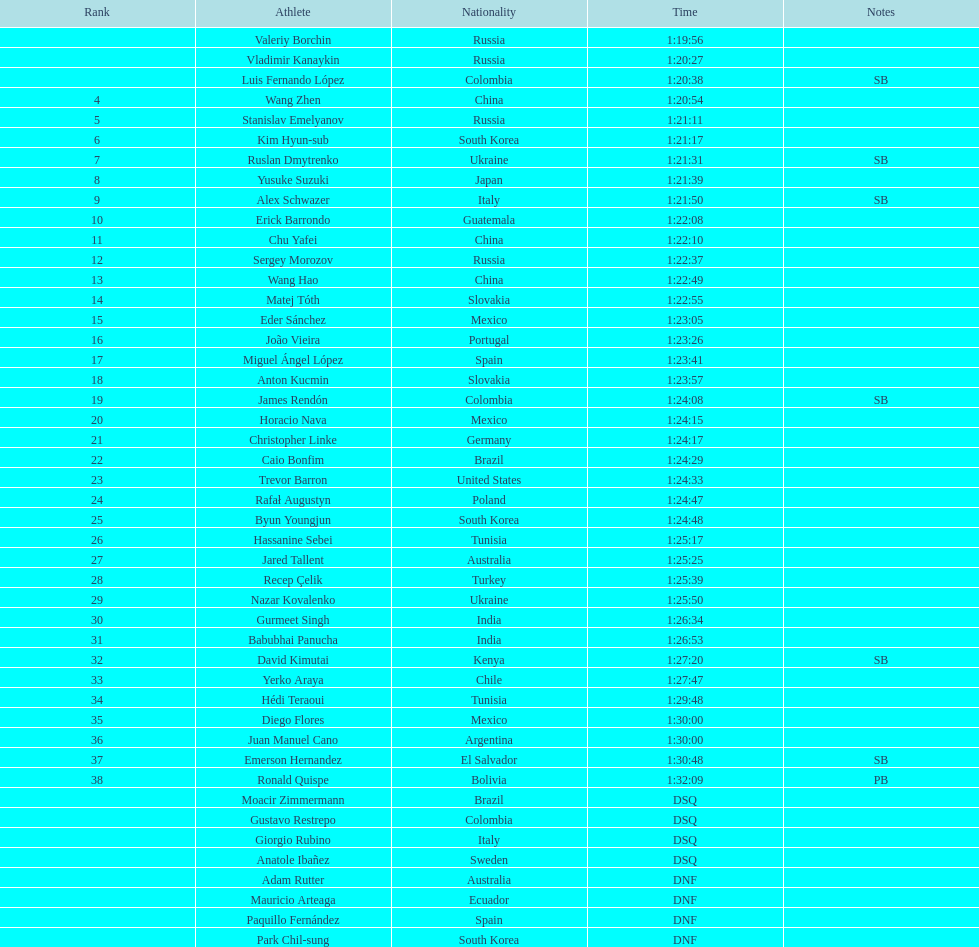How many russians finished at least 3rd in the 20km walk? 2. 